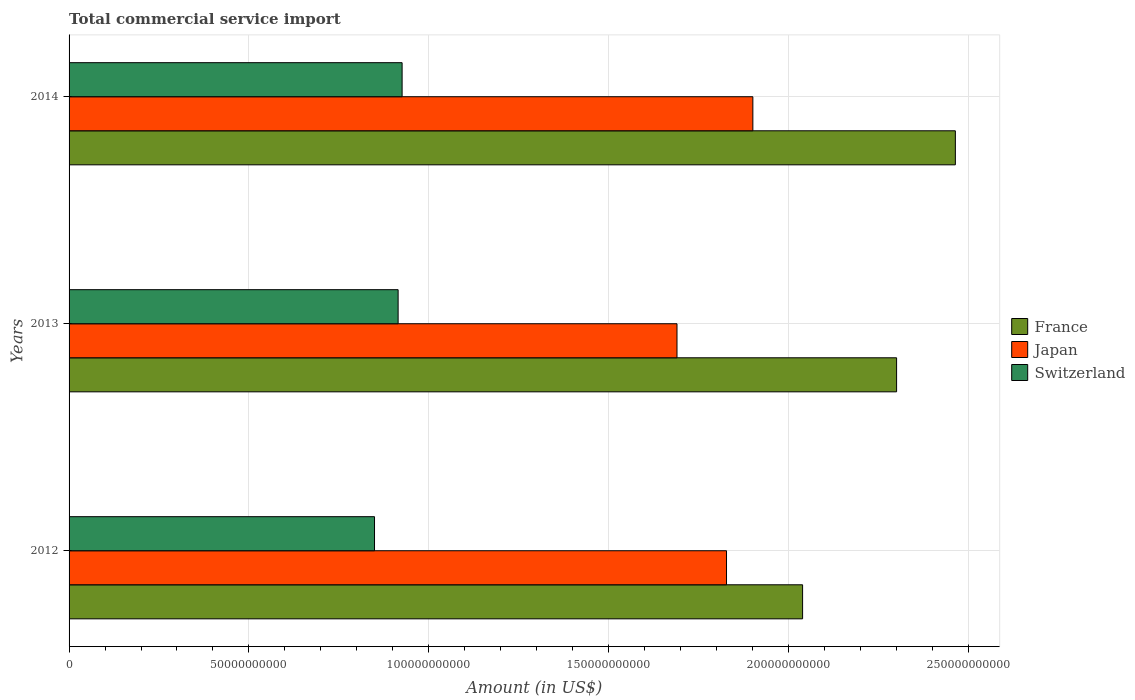How many groups of bars are there?
Your response must be concise. 3. In how many cases, is the number of bars for a given year not equal to the number of legend labels?
Make the answer very short. 0. What is the total commercial service import in Switzerland in 2013?
Keep it short and to the point. 9.15e+1. Across all years, what is the maximum total commercial service import in France?
Your answer should be compact. 2.46e+11. Across all years, what is the minimum total commercial service import in Japan?
Your response must be concise. 1.69e+11. In which year was the total commercial service import in France maximum?
Provide a short and direct response. 2014. In which year was the total commercial service import in Switzerland minimum?
Provide a succinct answer. 2012. What is the total total commercial service import in Switzerland in the graph?
Offer a very short reply. 2.69e+11. What is the difference between the total commercial service import in France in 2012 and that in 2014?
Offer a very short reply. -4.25e+1. What is the difference between the total commercial service import in Switzerland in 2014 and the total commercial service import in France in 2012?
Offer a very short reply. -1.11e+11. What is the average total commercial service import in Japan per year?
Provide a short and direct response. 1.81e+11. In the year 2014, what is the difference between the total commercial service import in Japan and total commercial service import in France?
Offer a very short reply. -5.63e+1. In how many years, is the total commercial service import in Japan greater than 70000000000 US$?
Make the answer very short. 3. What is the ratio of the total commercial service import in France in 2012 to that in 2014?
Ensure brevity in your answer.  0.83. Is the total commercial service import in Switzerland in 2012 less than that in 2014?
Provide a succinct answer. Yes. What is the difference between the highest and the second highest total commercial service import in Japan?
Give a very brief answer. 7.33e+09. What is the difference between the highest and the lowest total commercial service import in Switzerland?
Provide a short and direct response. 7.67e+09. In how many years, is the total commercial service import in France greater than the average total commercial service import in France taken over all years?
Give a very brief answer. 2. Is it the case that in every year, the sum of the total commercial service import in Switzerland and total commercial service import in France is greater than the total commercial service import in Japan?
Offer a terse response. Yes. How many bars are there?
Your answer should be very brief. 9. How many years are there in the graph?
Provide a succinct answer. 3. Are the values on the major ticks of X-axis written in scientific E-notation?
Provide a succinct answer. No. Does the graph contain any zero values?
Provide a short and direct response. No. Does the graph contain grids?
Your answer should be compact. Yes. How are the legend labels stacked?
Provide a succinct answer. Vertical. What is the title of the graph?
Offer a terse response. Total commercial service import. What is the label or title of the Y-axis?
Your answer should be compact. Years. What is the Amount (in US$) in France in 2012?
Provide a succinct answer. 2.04e+11. What is the Amount (in US$) in Japan in 2012?
Make the answer very short. 1.83e+11. What is the Amount (in US$) of Switzerland in 2012?
Your answer should be compact. 8.49e+1. What is the Amount (in US$) of France in 2013?
Make the answer very short. 2.30e+11. What is the Amount (in US$) of Japan in 2013?
Provide a short and direct response. 1.69e+11. What is the Amount (in US$) of Switzerland in 2013?
Provide a succinct answer. 9.15e+1. What is the Amount (in US$) in France in 2014?
Your answer should be very brief. 2.46e+11. What is the Amount (in US$) of Japan in 2014?
Your answer should be very brief. 1.90e+11. What is the Amount (in US$) of Switzerland in 2014?
Make the answer very short. 9.26e+1. Across all years, what is the maximum Amount (in US$) in France?
Your response must be concise. 2.46e+11. Across all years, what is the maximum Amount (in US$) in Japan?
Your answer should be very brief. 1.90e+11. Across all years, what is the maximum Amount (in US$) in Switzerland?
Keep it short and to the point. 9.26e+1. Across all years, what is the minimum Amount (in US$) of France?
Your answer should be compact. 2.04e+11. Across all years, what is the minimum Amount (in US$) in Japan?
Offer a very short reply. 1.69e+11. Across all years, what is the minimum Amount (in US$) in Switzerland?
Give a very brief answer. 8.49e+1. What is the total Amount (in US$) of France in the graph?
Keep it short and to the point. 6.81e+11. What is the total Amount (in US$) of Japan in the graph?
Your answer should be compact. 5.42e+11. What is the total Amount (in US$) of Switzerland in the graph?
Make the answer very short. 2.69e+11. What is the difference between the Amount (in US$) in France in 2012 and that in 2013?
Your response must be concise. -2.61e+1. What is the difference between the Amount (in US$) of Japan in 2012 and that in 2013?
Offer a very short reply. 1.38e+1. What is the difference between the Amount (in US$) of Switzerland in 2012 and that in 2013?
Your answer should be compact. -6.56e+09. What is the difference between the Amount (in US$) in France in 2012 and that in 2014?
Provide a succinct answer. -4.25e+1. What is the difference between the Amount (in US$) in Japan in 2012 and that in 2014?
Your response must be concise. -7.33e+09. What is the difference between the Amount (in US$) in Switzerland in 2012 and that in 2014?
Make the answer very short. -7.67e+09. What is the difference between the Amount (in US$) in France in 2013 and that in 2014?
Ensure brevity in your answer.  -1.63e+1. What is the difference between the Amount (in US$) of Japan in 2013 and that in 2014?
Keep it short and to the point. -2.11e+1. What is the difference between the Amount (in US$) of Switzerland in 2013 and that in 2014?
Give a very brief answer. -1.11e+09. What is the difference between the Amount (in US$) of France in 2012 and the Amount (in US$) of Japan in 2013?
Make the answer very short. 3.49e+1. What is the difference between the Amount (in US$) in France in 2012 and the Amount (in US$) in Switzerland in 2013?
Make the answer very short. 1.12e+11. What is the difference between the Amount (in US$) of Japan in 2012 and the Amount (in US$) of Switzerland in 2013?
Give a very brief answer. 9.13e+1. What is the difference between the Amount (in US$) of France in 2012 and the Amount (in US$) of Japan in 2014?
Give a very brief answer. 1.38e+1. What is the difference between the Amount (in US$) of France in 2012 and the Amount (in US$) of Switzerland in 2014?
Make the answer very short. 1.11e+11. What is the difference between the Amount (in US$) of Japan in 2012 and the Amount (in US$) of Switzerland in 2014?
Your response must be concise. 9.02e+1. What is the difference between the Amount (in US$) in France in 2013 and the Amount (in US$) in Japan in 2014?
Provide a short and direct response. 4.00e+1. What is the difference between the Amount (in US$) of France in 2013 and the Amount (in US$) of Switzerland in 2014?
Provide a succinct answer. 1.38e+11. What is the difference between the Amount (in US$) of Japan in 2013 and the Amount (in US$) of Switzerland in 2014?
Ensure brevity in your answer.  7.64e+1. What is the average Amount (in US$) of France per year?
Ensure brevity in your answer.  2.27e+11. What is the average Amount (in US$) in Japan per year?
Your answer should be very brief. 1.81e+11. What is the average Amount (in US$) of Switzerland per year?
Provide a succinct answer. 8.97e+1. In the year 2012, what is the difference between the Amount (in US$) in France and Amount (in US$) in Japan?
Provide a succinct answer. 2.12e+1. In the year 2012, what is the difference between the Amount (in US$) in France and Amount (in US$) in Switzerland?
Ensure brevity in your answer.  1.19e+11. In the year 2012, what is the difference between the Amount (in US$) of Japan and Amount (in US$) of Switzerland?
Offer a very short reply. 9.79e+1. In the year 2013, what is the difference between the Amount (in US$) of France and Amount (in US$) of Japan?
Make the answer very short. 6.11e+1. In the year 2013, what is the difference between the Amount (in US$) in France and Amount (in US$) in Switzerland?
Ensure brevity in your answer.  1.39e+11. In the year 2013, what is the difference between the Amount (in US$) in Japan and Amount (in US$) in Switzerland?
Ensure brevity in your answer.  7.75e+1. In the year 2014, what is the difference between the Amount (in US$) in France and Amount (in US$) in Japan?
Your answer should be compact. 5.63e+1. In the year 2014, what is the difference between the Amount (in US$) of France and Amount (in US$) of Switzerland?
Make the answer very short. 1.54e+11. In the year 2014, what is the difference between the Amount (in US$) in Japan and Amount (in US$) in Switzerland?
Provide a succinct answer. 9.75e+1. What is the ratio of the Amount (in US$) in France in 2012 to that in 2013?
Ensure brevity in your answer.  0.89. What is the ratio of the Amount (in US$) in Japan in 2012 to that in 2013?
Make the answer very short. 1.08. What is the ratio of the Amount (in US$) in Switzerland in 2012 to that in 2013?
Provide a short and direct response. 0.93. What is the ratio of the Amount (in US$) of France in 2012 to that in 2014?
Offer a very short reply. 0.83. What is the ratio of the Amount (in US$) in Japan in 2012 to that in 2014?
Ensure brevity in your answer.  0.96. What is the ratio of the Amount (in US$) of Switzerland in 2012 to that in 2014?
Ensure brevity in your answer.  0.92. What is the ratio of the Amount (in US$) of France in 2013 to that in 2014?
Make the answer very short. 0.93. What is the ratio of the Amount (in US$) of Japan in 2013 to that in 2014?
Offer a very short reply. 0.89. What is the ratio of the Amount (in US$) of Switzerland in 2013 to that in 2014?
Your response must be concise. 0.99. What is the difference between the highest and the second highest Amount (in US$) of France?
Your answer should be compact. 1.63e+1. What is the difference between the highest and the second highest Amount (in US$) in Japan?
Give a very brief answer. 7.33e+09. What is the difference between the highest and the second highest Amount (in US$) in Switzerland?
Offer a terse response. 1.11e+09. What is the difference between the highest and the lowest Amount (in US$) in France?
Ensure brevity in your answer.  4.25e+1. What is the difference between the highest and the lowest Amount (in US$) of Japan?
Your answer should be compact. 2.11e+1. What is the difference between the highest and the lowest Amount (in US$) of Switzerland?
Keep it short and to the point. 7.67e+09. 